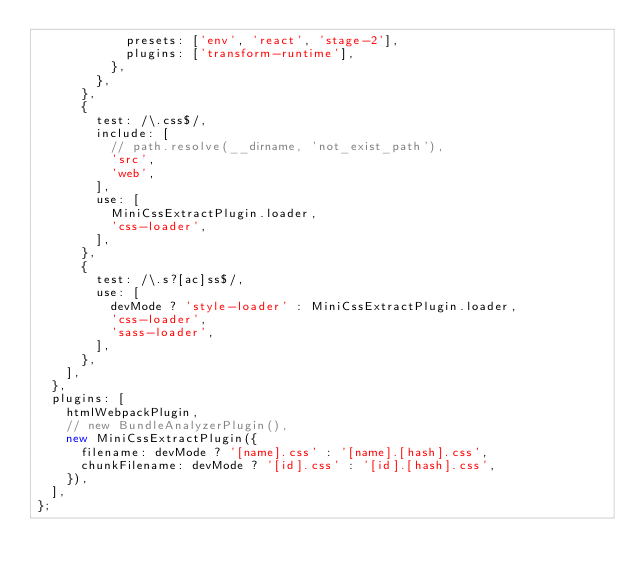<code> <loc_0><loc_0><loc_500><loc_500><_JavaScript_>            presets: ['env', 'react', 'stage-2'],
            plugins: ['transform-runtime'],
          },
        },
      },
      {
        test: /\.css$/,
        include: [
          // path.resolve(__dirname, 'not_exist_path'),
          'src',
          'web',
        ],
        use: [
          MiniCssExtractPlugin.loader,
          'css-loader',
        ],
      },
      {
        test: /\.s?[ac]ss$/,
        use: [
          devMode ? 'style-loader' : MiniCssExtractPlugin.loader,
          'css-loader',
          'sass-loader',
        ],
      },
    ],
  },
  plugins: [
    htmlWebpackPlugin,
    // new BundleAnalyzerPlugin(),
    new MiniCssExtractPlugin({
      filename: devMode ? '[name].css' : '[name].[hash].css',
      chunkFilename: devMode ? '[id].css' : '[id].[hash].css',
    }),
  ],
};
</code> 